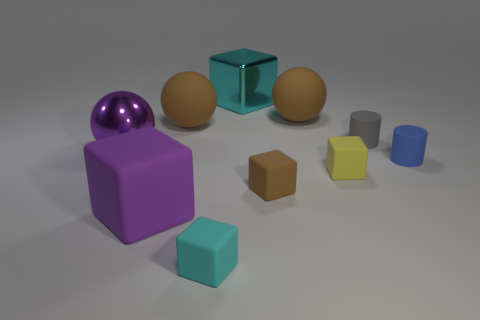Subtract all spheres. How many objects are left? 7 Subtract all small rubber cylinders. Subtract all blue things. How many objects are left? 7 Add 8 purple objects. How many purple objects are left? 10 Add 4 small blue rubber cylinders. How many small blue rubber cylinders exist? 5 Subtract 0 gray balls. How many objects are left? 10 